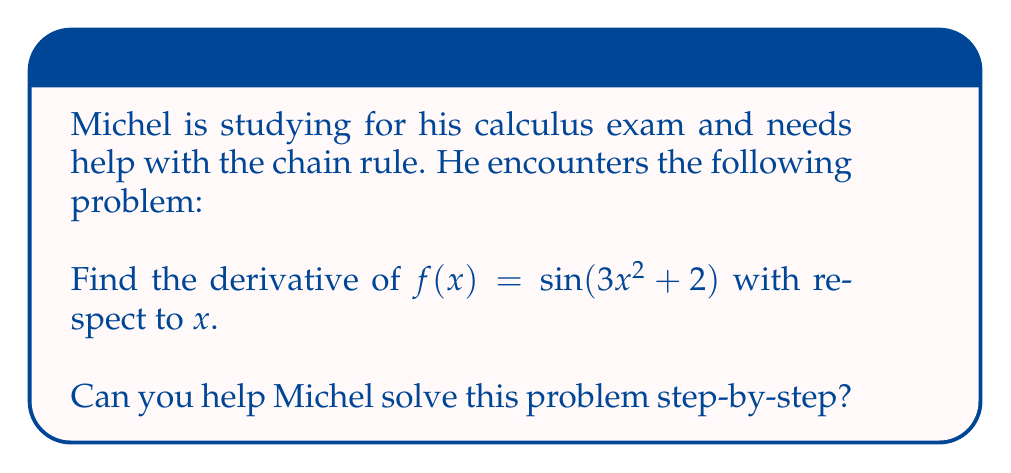What is the answer to this math problem? Let's help Michel solve this problem using the chain rule:

1) First, we identify the composite function:
   $f(x) = \sin(u)$, where $u = 3x^2 + 2$

2) The chain rule states that:
   $$\frac{df}{dx} = \frac{df}{du} \cdot \frac{du}{dx}$$

3) Let's find $\frac{df}{du}$:
   $\frac{df}{du} = \cos(u)$ (derivative of sine is cosine)

4) Now, let's find $\frac{du}{dx}$:
   $u = 3x^2 + 2$
   $\frac{du}{dx} = 6x$ (derivative of $3x^2$ is $6x$, and the derivative of 2 is 0)

5) Applying the chain rule:
   $$\frac{df}{dx} = \cos(u) \cdot 6x$$

6) Substituting back $u = 3x^2 + 2$:
   $$\frac{df}{dx} = \cos(3x^2 + 2) \cdot 6x$$

Therefore, the derivative of $f(x) = \sin(3x^2 + 2)$ is $6x\cos(3x^2 + 2)$.
Answer: $6x\cos(3x^2 + 2)$ 